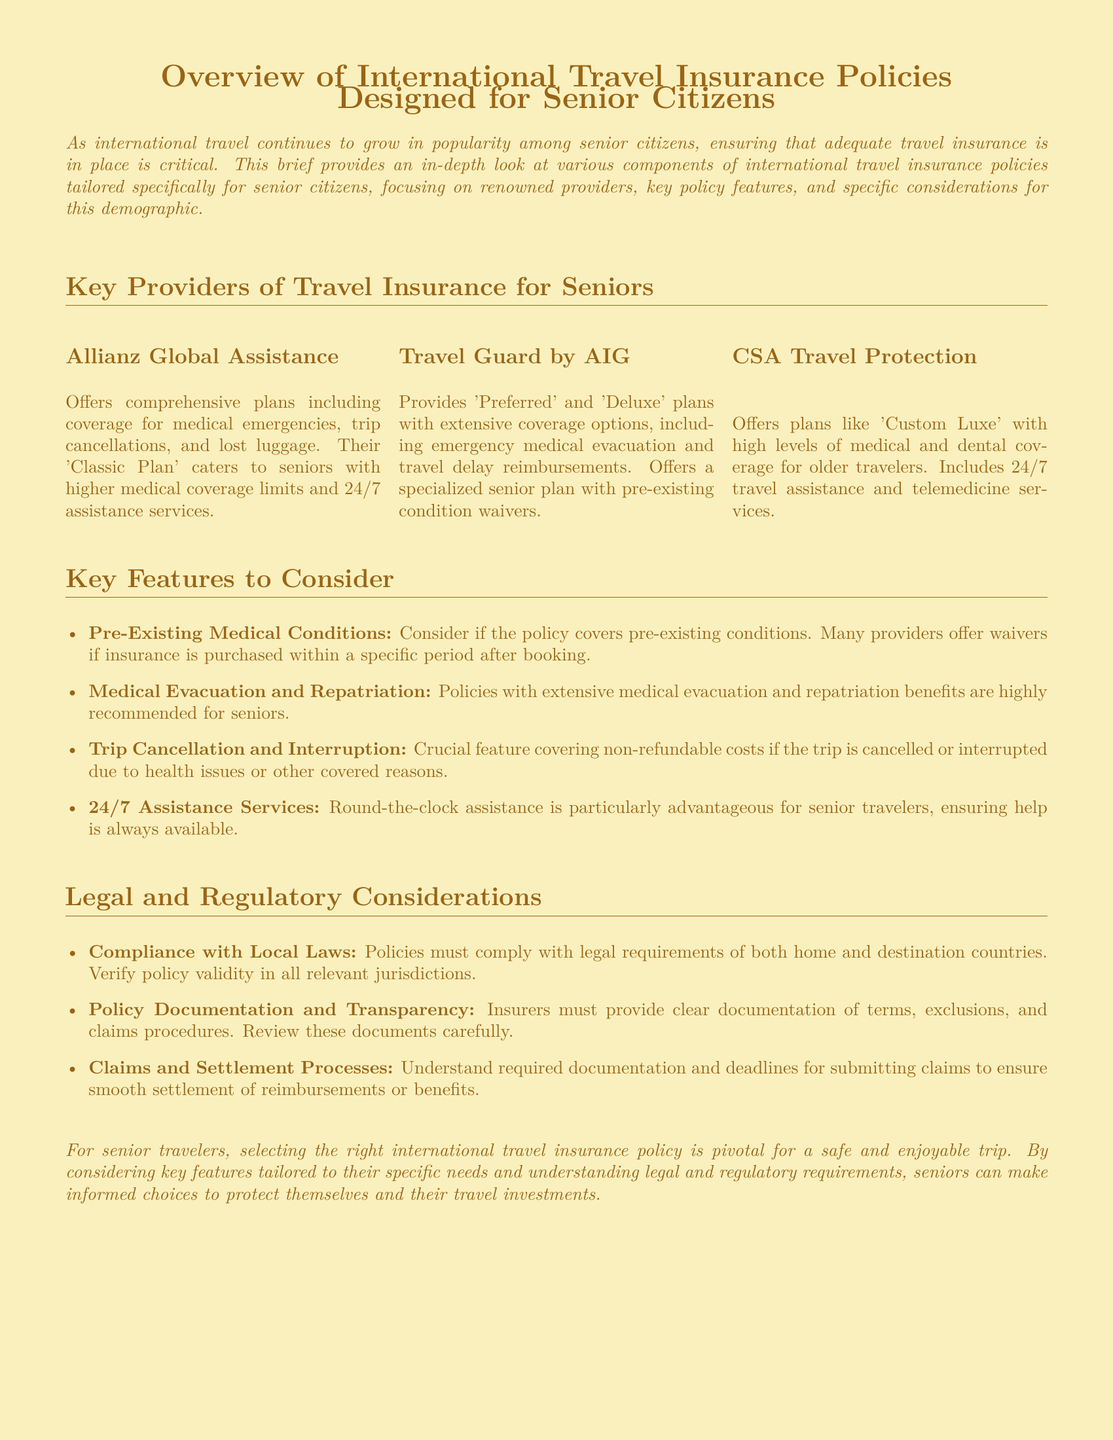What is the title of the document? The title of the document is provided in the header, outlining the subject matter.
Answer: Overview of International Travel Insurance Policies Designed for Senior Citizens Which provider offers the 'Classic Plan' for seniors? The document mentions that Allianz Global Assistance has a plan specifically for seniors.
Answer: Allianz Global Assistance What feature covers non-refundable costs if a trip is cancelled? The document lists trip cancellation and interruption as a crucial feature for travel insurance.
Answer: Trip Cancellation and Interruption What type of services should seniors expect in their travel insurance? The document highlights the importance of 24/7 assistance services for senior travelers.
Answer: 24/7 Assistance Services Which provider includes telemedicine services? CSA Travel Protection is specifically noted for including telemedicine services in its plans.
Answer: CSA Travel Protection What is necessary to verify about the insurance policy regarding local laws? The document emphasizes the need for compliance with legal requirements in both home and destination countries.
Answer: Compliance with Local Laws What kind of benefits are highly recommended for seniors in travel insurance? The document states that extensive medical evacuation and repatriation benefits are highly recommended for seniors.
Answer: Medical Evacuation and Repatriation What is a key consideration regarding pre-existing medical conditions? Many providers offer waivers if insurance is purchased within a specific period after booking, according to the document.
Answer: Waivers What aspect of policy documentation is important for insurers? Transparency in terms, exclusions, and claims procedures is highlighted as crucial in the document.
Answer: Policy Documentation and Transparency 